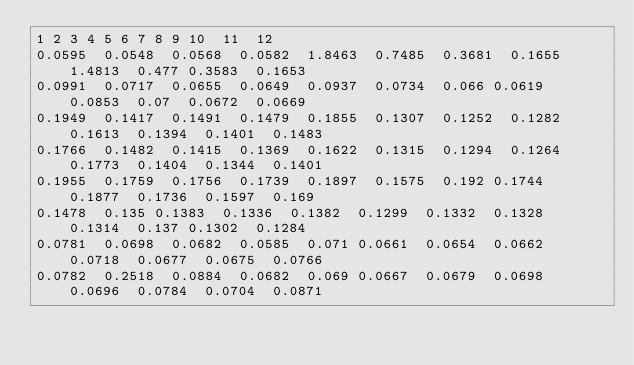Convert code to text. <code><loc_0><loc_0><loc_500><loc_500><_SQL_>1	2	3	4	5	6	7	8	9	10	11	12
0.0595	0.0548	0.0568	0.0582	1.8463	0.7485	0.3681	0.1655	1.4813	0.477	0.3583	0.1653
0.0991	0.0717	0.0655	0.0649	0.0937	0.0734	0.066	0.0619	0.0853	0.07	0.0672	0.0669
0.1949	0.1417	0.1491	0.1479	0.1855	0.1307	0.1252	0.1282	0.1613	0.1394	0.1401	0.1483
0.1766	0.1482	0.1415	0.1369	0.1622	0.1315	0.1294	0.1264	0.1773	0.1404	0.1344	0.1401
0.1955	0.1759	0.1756	0.1739	0.1897	0.1575	0.192	0.1744	0.1877	0.1736	0.1597	0.169
0.1478	0.135	0.1383	0.1336	0.1382	0.1299	0.1332	0.1328	0.1314	0.137	0.1302	0.1284
0.0781	0.0698	0.0682	0.0585	0.071	0.0661	0.0654	0.0662	0.0718	0.0677	0.0675	0.0766
0.0782	0.2518	0.0884	0.0682	0.069	0.0667	0.0679	0.0698	0.0696	0.0784	0.0704	0.0871
</code> 